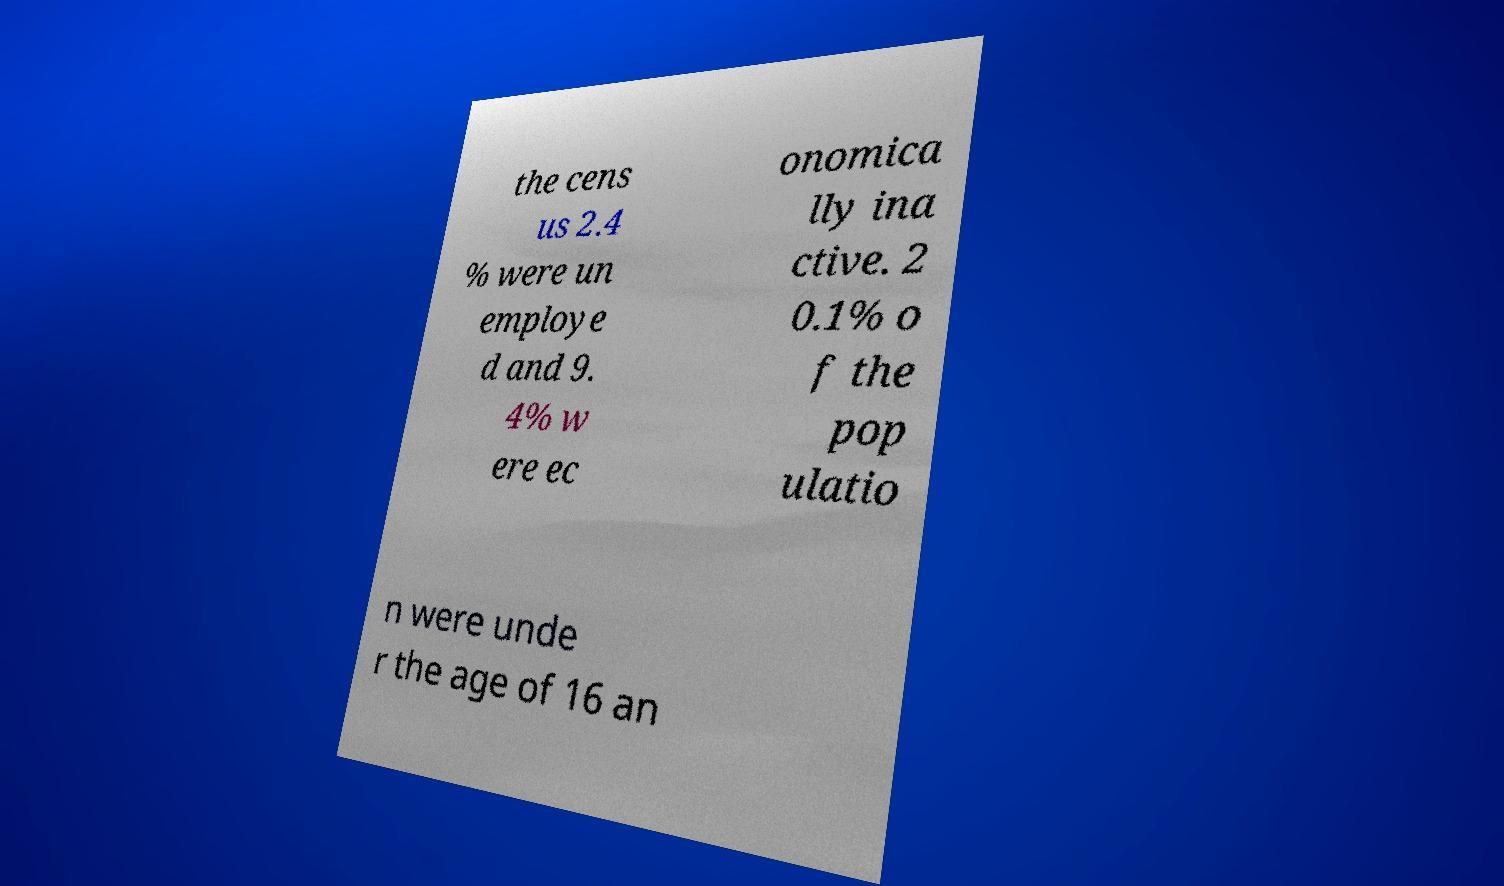Could you assist in decoding the text presented in this image and type it out clearly? the cens us 2.4 % were un employe d and 9. 4% w ere ec onomica lly ina ctive. 2 0.1% o f the pop ulatio n were unde r the age of 16 an 